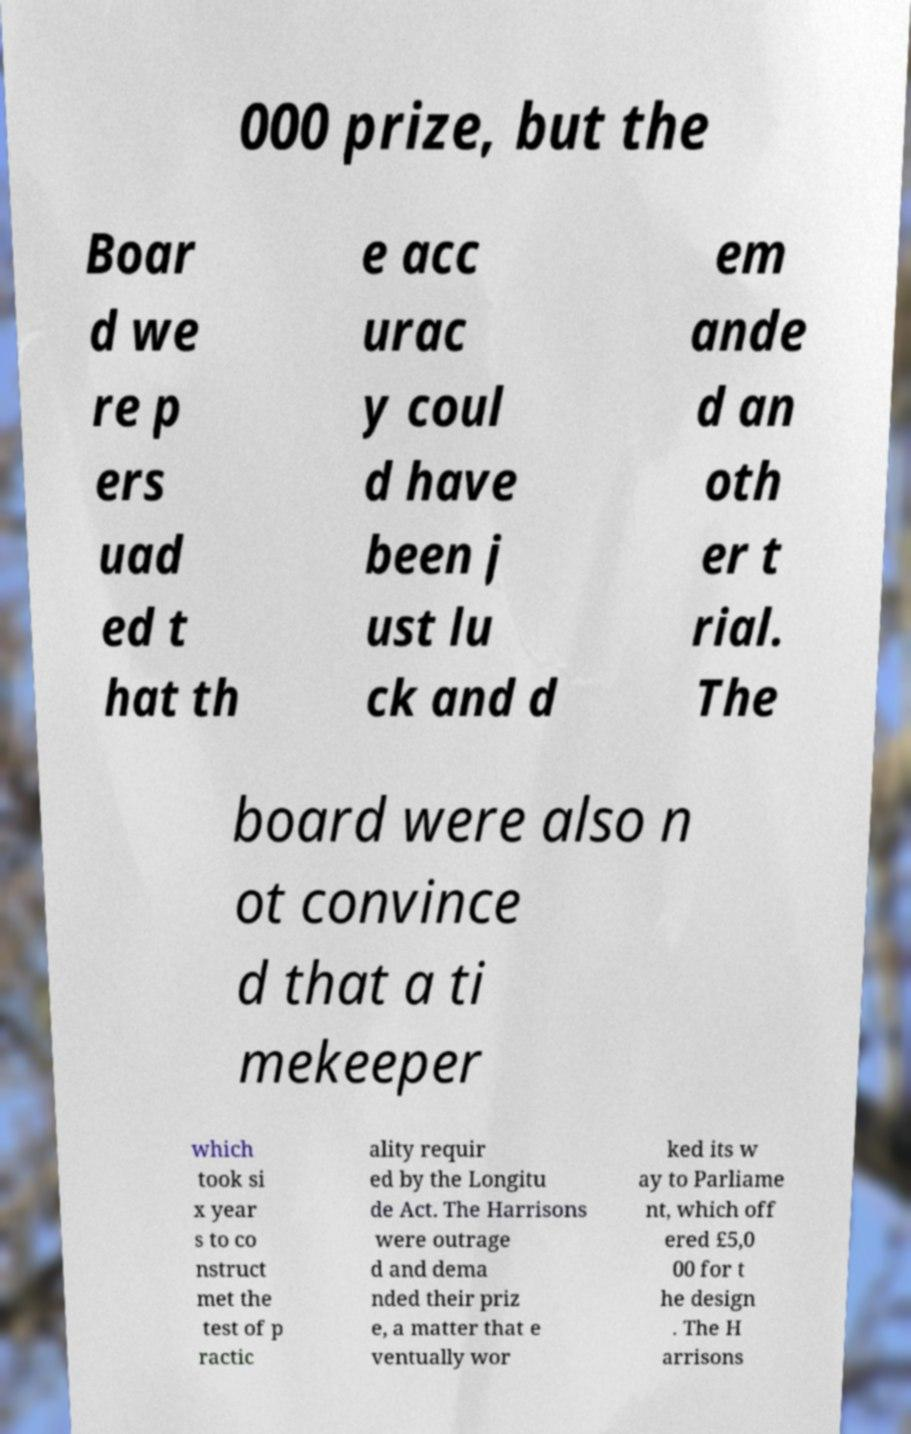What messages or text are displayed in this image? I need them in a readable, typed format. 000 prize, but the Boar d we re p ers uad ed t hat th e acc urac y coul d have been j ust lu ck and d em ande d an oth er t rial. The board were also n ot convince d that a ti mekeeper which took si x year s to co nstruct met the test of p ractic ality requir ed by the Longitu de Act. The Harrisons were outrage d and dema nded their priz e, a matter that e ventually wor ked its w ay to Parliame nt, which off ered £5,0 00 for t he design . The H arrisons 